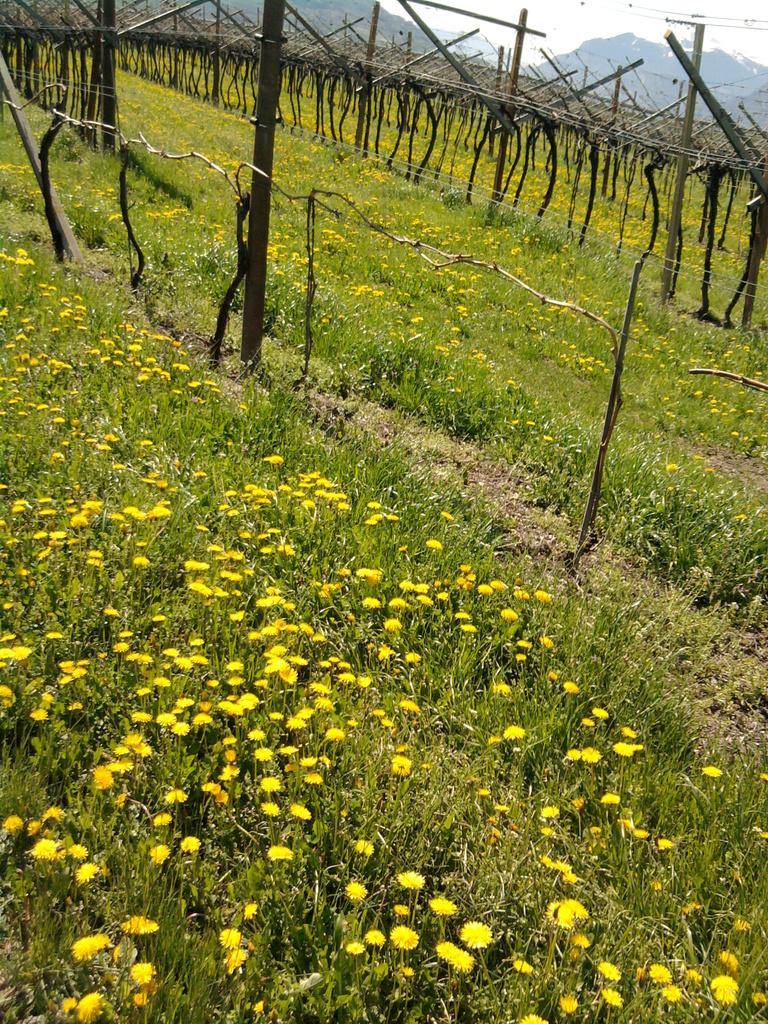What type of outdoor space is shown in the image? There is a garden in the image. What color are the flowers in the garden? The garden is filled with yellow flowers. What type of material are the poles in the garden made of? The wooden poles are visible in the garden. What can be seen in the distance in the image? There are hills visible in the background of the image. What is visible above the garden in the image? The sky is visible in the background of the image. What type of discussion is taking place in the garden in the image? There is no discussion taking place in the garden in the image; it is a still image of a garden filled with yellow flowers, wooden poles, hills, and the sky. 